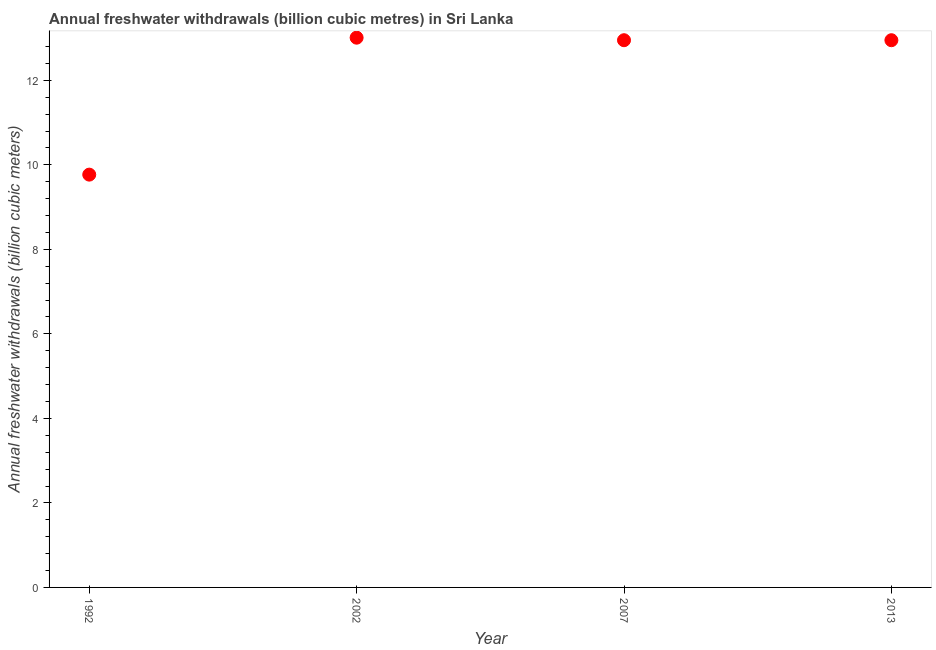What is the annual freshwater withdrawals in 1992?
Your answer should be very brief. 9.77. Across all years, what is the maximum annual freshwater withdrawals?
Keep it short and to the point. 13.01. Across all years, what is the minimum annual freshwater withdrawals?
Provide a short and direct response. 9.77. In which year was the annual freshwater withdrawals maximum?
Your answer should be compact. 2002. What is the sum of the annual freshwater withdrawals?
Provide a short and direct response. 48.68. What is the difference between the annual freshwater withdrawals in 2002 and 2013?
Give a very brief answer. 0.06. What is the average annual freshwater withdrawals per year?
Your answer should be compact. 12.17. What is the median annual freshwater withdrawals?
Provide a succinct answer. 12.95. Do a majority of the years between 1992 and 2013 (inclusive) have annual freshwater withdrawals greater than 3.6 billion cubic meters?
Your answer should be compact. Yes. What is the ratio of the annual freshwater withdrawals in 1992 to that in 2007?
Your answer should be compact. 0.75. Is the annual freshwater withdrawals in 1992 less than that in 2013?
Keep it short and to the point. Yes. What is the difference between the highest and the second highest annual freshwater withdrawals?
Give a very brief answer. 0.06. What is the difference between the highest and the lowest annual freshwater withdrawals?
Offer a terse response. 3.24. Does the annual freshwater withdrawals monotonically increase over the years?
Your answer should be very brief. No. What is the difference between two consecutive major ticks on the Y-axis?
Your answer should be very brief. 2. Does the graph contain any zero values?
Ensure brevity in your answer.  No. Does the graph contain grids?
Provide a short and direct response. No. What is the title of the graph?
Offer a very short reply. Annual freshwater withdrawals (billion cubic metres) in Sri Lanka. What is the label or title of the Y-axis?
Make the answer very short. Annual freshwater withdrawals (billion cubic meters). What is the Annual freshwater withdrawals (billion cubic meters) in 1992?
Offer a very short reply. 9.77. What is the Annual freshwater withdrawals (billion cubic meters) in 2002?
Your answer should be compact. 13.01. What is the Annual freshwater withdrawals (billion cubic meters) in 2007?
Your answer should be compact. 12.95. What is the Annual freshwater withdrawals (billion cubic meters) in 2013?
Your answer should be compact. 12.95. What is the difference between the Annual freshwater withdrawals (billion cubic meters) in 1992 and 2002?
Provide a short and direct response. -3.24. What is the difference between the Annual freshwater withdrawals (billion cubic meters) in 1992 and 2007?
Your response must be concise. -3.18. What is the difference between the Annual freshwater withdrawals (billion cubic meters) in 1992 and 2013?
Ensure brevity in your answer.  -3.18. What is the difference between the Annual freshwater withdrawals (billion cubic meters) in 2007 and 2013?
Ensure brevity in your answer.  0. What is the ratio of the Annual freshwater withdrawals (billion cubic meters) in 1992 to that in 2002?
Provide a succinct answer. 0.75. What is the ratio of the Annual freshwater withdrawals (billion cubic meters) in 1992 to that in 2007?
Your answer should be very brief. 0.75. What is the ratio of the Annual freshwater withdrawals (billion cubic meters) in 1992 to that in 2013?
Provide a short and direct response. 0.75. What is the ratio of the Annual freshwater withdrawals (billion cubic meters) in 2007 to that in 2013?
Provide a succinct answer. 1. 